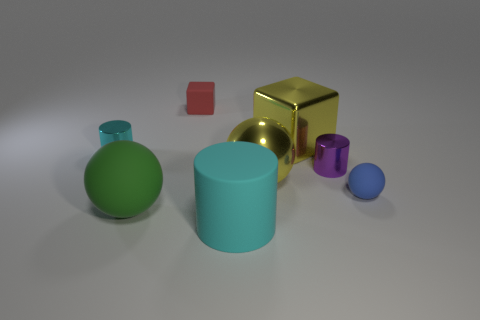What size is the purple object?
Your answer should be very brief. Small. Is the material of the tiny cylinder to the right of the metal block the same as the blue sphere?
Your response must be concise. No. Is the shape of the tiny purple shiny object the same as the blue rubber thing?
Your response must be concise. No. The metallic thing that is behind the small thing that is on the left side of the rubber ball that is in front of the tiny blue matte object is what shape?
Offer a very short reply. Cube. Is the shape of the matte object that is to the right of the big yellow block the same as the small metallic object on the right side of the red block?
Make the answer very short. No. Is there a tiny red block made of the same material as the small ball?
Offer a terse response. Yes. What is the color of the small matte object right of the small metallic thing in front of the tiny cylinder that is left of the small red matte thing?
Your response must be concise. Blue. Is the purple thing to the right of the red cube made of the same material as the cyan cylinder that is behind the blue matte thing?
Keep it short and to the point. Yes. There is a yellow thing that is behind the tiny cyan metal cylinder; what shape is it?
Make the answer very short. Cube. What number of objects are large balls or blue objects that are right of the yellow cube?
Ensure brevity in your answer.  3. 